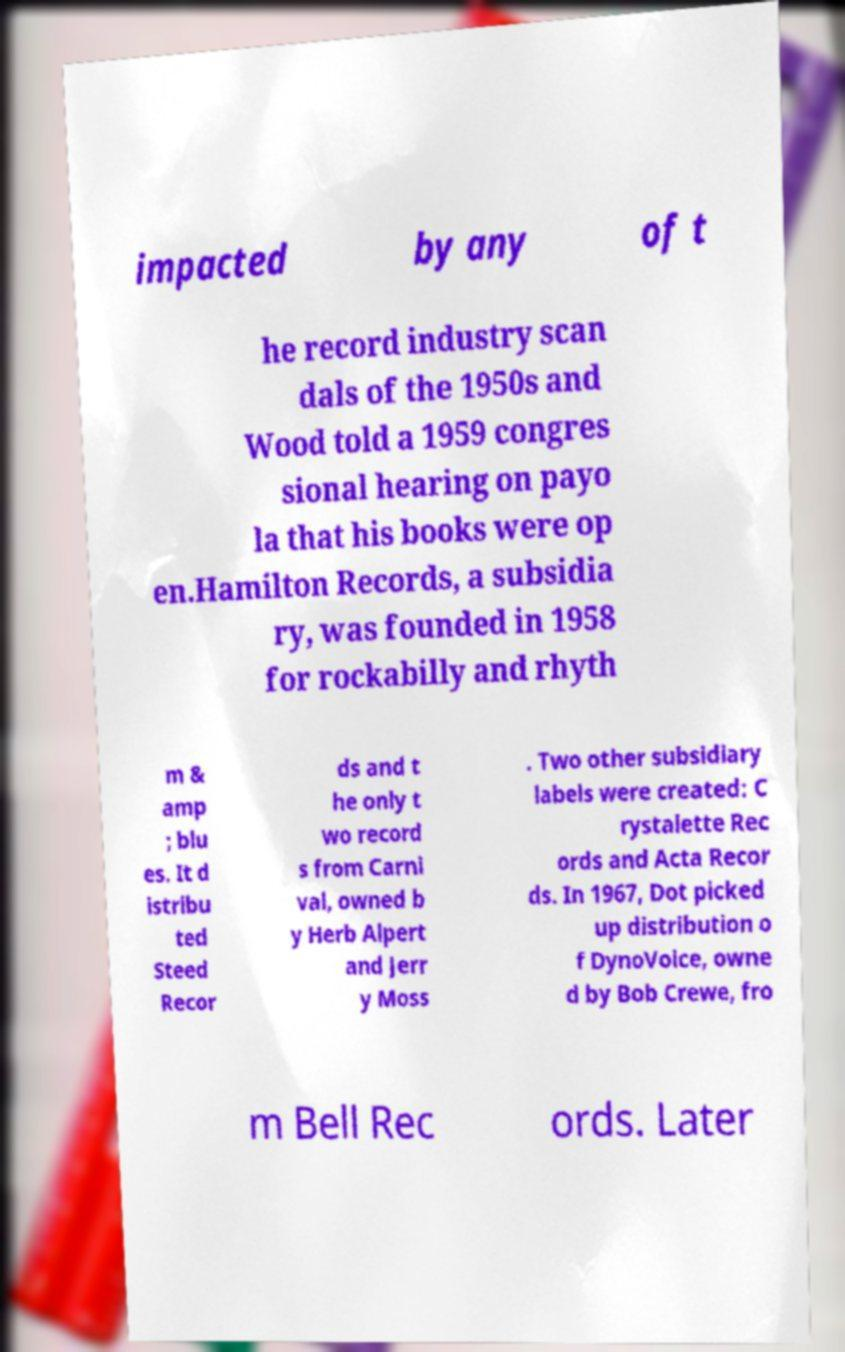For documentation purposes, I need the text within this image transcribed. Could you provide that? impacted by any of t he record industry scan dals of the 1950s and Wood told a 1959 congres sional hearing on payo la that his books were op en.Hamilton Records, a subsidia ry, was founded in 1958 for rockabilly and rhyth m & amp ; blu es. It d istribu ted Steed Recor ds and t he only t wo record s from Carni val, owned b y Herb Alpert and Jerr y Moss . Two other subsidiary labels were created: C rystalette Rec ords and Acta Recor ds. In 1967, Dot picked up distribution o f DynoVoice, owne d by Bob Crewe, fro m Bell Rec ords. Later 